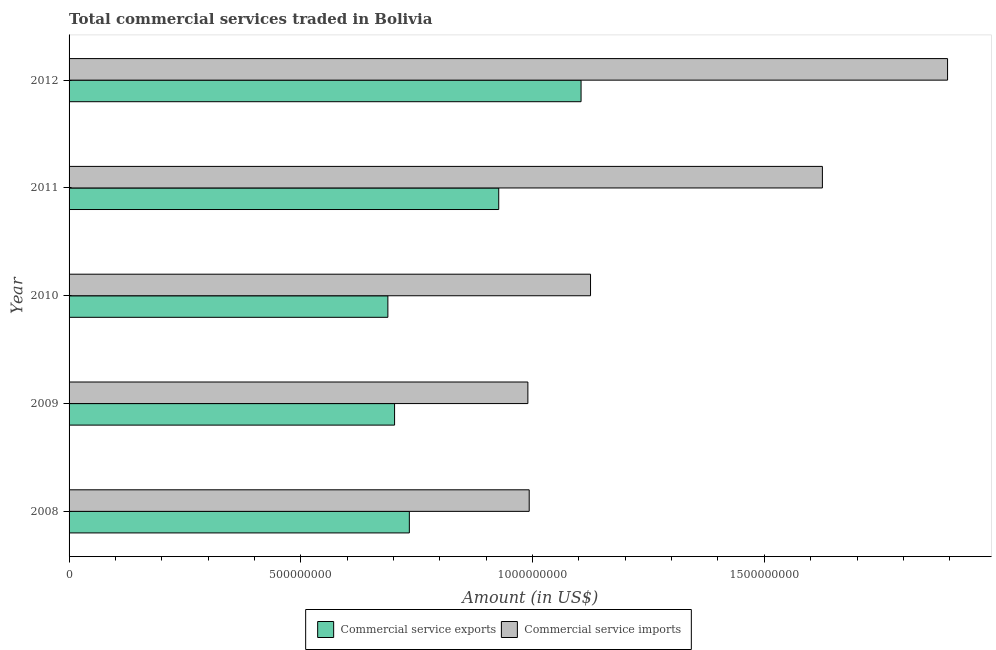Are the number of bars per tick equal to the number of legend labels?
Offer a terse response. Yes. Are the number of bars on each tick of the Y-axis equal?
Provide a succinct answer. Yes. What is the label of the 4th group of bars from the top?
Your response must be concise. 2009. What is the amount of commercial service exports in 2012?
Offer a terse response. 1.10e+09. Across all years, what is the maximum amount of commercial service imports?
Your answer should be very brief. 1.90e+09. Across all years, what is the minimum amount of commercial service exports?
Give a very brief answer. 6.88e+08. In which year was the amount of commercial service exports maximum?
Offer a terse response. 2012. What is the total amount of commercial service imports in the graph?
Offer a terse response. 6.63e+09. What is the difference between the amount of commercial service exports in 2010 and that in 2012?
Your response must be concise. -4.17e+08. What is the difference between the amount of commercial service exports in 2010 and the amount of commercial service imports in 2012?
Make the answer very short. -1.21e+09. What is the average amount of commercial service exports per year?
Your answer should be very brief. 8.31e+08. In the year 2009, what is the difference between the amount of commercial service imports and amount of commercial service exports?
Provide a short and direct response. 2.88e+08. In how many years, is the amount of commercial service exports greater than 1700000000 US$?
Your answer should be compact. 0. What is the ratio of the amount of commercial service imports in 2010 to that in 2012?
Your response must be concise. 0.59. What is the difference between the highest and the second highest amount of commercial service exports?
Your answer should be very brief. 1.78e+08. What is the difference between the highest and the lowest amount of commercial service imports?
Provide a succinct answer. 9.05e+08. In how many years, is the amount of commercial service imports greater than the average amount of commercial service imports taken over all years?
Offer a terse response. 2. Is the sum of the amount of commercial service exports in 2008 and 2012 greater than the maximum amount of commercial service imports across all years?
Make the answer very short. No. What does the 1st bar from the top in 2010 represents?
Keep it short and to the point. Commercial service imports. What does the 2nd bar from the bottom in 2011 represents?
Provide a short and direct response. Commercial service imports. How many bars are there?
Offer a terse response. 10. How many years are there in the graph?
Give a very brief answer. 5. What is the difference between two consecutive major ticks on the X-axis?
Your response must be concise. 5.00e+08. Are the values on the major ticks of X-axis written in scientific E-notation?
Provide a short and direct response. No. Does the graph contain any zero values?
Offer a terse response. No. Where does the legend appear in the graph?
Provide a succinct answer. Bottom center. How are the legend labels stacked?
Your response must be concise. Horizontal. What is the title of the graph?
Your answer should be very brief. Total commercial services traded in Bolivia. Does "Secondary" appear as one of the legend labels in the graph?
Offer a very short reply. No. What is the Amount (in US$) of Commercial service exports in 2008?
Give a very brief answer. 7.34e+08. What is the Amount (in US$) in Commercial service imports in 2008?
Provide a succinct answer. 9.93e+08. What is the Amount (in US$) of Commercial service exports in 2009?
Provide a succinct answer. 7.02e+08. What is the Amount (in US$) in Commercial service imports in 2009?
Ensure brevity in your answer.  9.90e+08. What is the Amount (in US$) of Commercial service exports in 2010?
Offer a terse response. 6.88e+08. What is the Amount (in US$) of Commercial service imports in 2010?
Your response must be concise. 1.13e+09. What is the Amount (in US$) in Commercial service exports in 2011?
Your answer should be very brief. 9.27e+08. What is the Amount (in US$) in Commercial service imports in 2011?
Ensure brevity in your answer.  1.63e+09. What is the Amount (in US$) in Commercial service exports in 2012?
Offer a terse response. 1.10e+09. What is the Amount (in US$) of Commercial service imports in 2012?
Your answer should be very brief. 1.90e+09. Across all years, what is the maximum Amount (in US$) in Commercial service exports?
Make the answer very short. 1.10e+09. Across all years, what is the maximum Amount (in US$) of Commercial service imports?
Keep it short and to the point. 1.90e+09. Across all years, what is the minimum Amount (in US$) of Commercial service exports?
Ensure brevity in your answer.  6.88e+08. Across all years, what is the minimum Amount (in US$) of Commercial service imports?
Ensure brevity in your answer.  9.90e+08. What is the total Amount (in US$) in Commercial service exports in the graph?
Provide a succinct answer. 4.16e+09. What is the total Amount (in US$) of Commercial service imports in the graph?
Keep it short and to the point. 6.63e+09. What is the difference between the Amount (in US$) in Commercial service exports in 2008 and that in 2009?
Offer a terse response. 3.18e+07. What is the difference between the Amount (in US$) of Commercial service imports in 2008 and that in 2009?
Make the answer very short. 2.86e+06. What is the difference between the Amount (in US$) in Commercial service exports in 2008 and that in 2010?
Ensure brevity in your answer.  4.63e+07. What is the difference between the Amount (in US$) in Commercial service imports in 2008 and that in 2010?
Keep it short and to the point. -1.32e+08. What is the difference between the Amount (in US$) in Commercial service exports in 2008 and that in 2011?
Give a very brief answer. -1.93e+08. What is the difference between the Amount (in US$) in Commercial service imports in 2008 and that in 2011?
Provide a succinct answer. -6.33e+08. What is the difference between the Amount (in US$) in Commercial service exports in 2008 and that in 2012?
Offer a terse response. -3.70e+08. What is the difference between the Amount (in US$) in Commercial service imports in 2008 and that in 2012?
Your response must be concise. -9.03e+08. What is the difference between the Amount (in US$) of Commercial service exports in 2009 and that in 2010?
Offer a terse response. 1.45e+07. What is the difference between the Amount (in US$) of Commercial service imports in 2009 and that in 2010?
Give a very brief answer. -1.35e+08. What is the difference between the Amount (in US$) in Commercial service exports in 2009 and that in 2011?
Your answer should be compact. -2.25e+08. What is the difference between the Amount (in US$) in Commercial service imports in 2009 and that in 2011?
Your answer should be compact. -6.35e+08. What is the difference between the Amount (in US$) in Commercial service exports in 2009 and that in 2012?
Provide a short and direct response. -4.02e+08. What is the difference between the Amount (in US$) of Commercial service imports in 2009 and that in 2012?
Offer a terse response. -9.05e+08. What is the difference between the Amount (in US$) in Commercial service exports in 2010 and that in 2011?
Make the answer very short. -2.39e+08. What is the difference between the Amount (in US$) of Commercial service imports in 2010 and that in 2011?
Give a very brief answer. -5.00e+08. What is the difference between the Amount (in US$) in Commercial service exports in 2010 and that in 2012?
Your response must be concise. -4.17e+08. What is the difference between the Amount (in US$) in Commercial service imports in 2010 and that in 2012?
Your response must be concise. -7.70e+08. What is the difference between the Amount (in US$) in Commercial service exports in 2011 and that in 2012?
Ensure brevity in your answer.  -1.78e+08. What is the difference between the Amount (in US$) in Commercial service imports in 2011 and that in 2012?
Make the answer very short. -2.70e+08. What is the difference between the Amount (in US$) in Commercial service exports in 2008 and the Amount (in US$) in Commercial service imports in 2009?
Offer a very short reply. -2.56e+08. What is the difference between the Amount (in US$) in Commercial service exports in 2008 and the Amount (in US$) in Commercial service imports in 2010?
Keep it short and to the point. -3.91e+08. What is the difference between the Amount (in US$) in Commercial service exports in 2008 and the Amount (in US$) in Commercial service imports in 2011?
Offer a terse response. -8.91e+08. What is the difference between the Amount (in US$) of Commercial service exports in 2008 and the Amount (in US$) of Commercial service imports in 2012?
Make the answer very short. -1.16e+09. What is the difference between the Amount (in US$) of Commercial service exports in 2009 and the Amount (in US$) of Commercial service imports in 2010?
Ensure brevity in your answer.  -4.23e+08. What is the difference between the Amount (in US$) of Commercial service exports in 2009 and the Amount (in US$) of Commercial service imports in 2011?
Your answer should be compact. -9.23e+08. What is the difference between the Amount (in US$) of Commercial service exports in 2009 and the Amount (in US$) of Commercial service imports in 2012?
Ensure brevity in your answer.  -1.19e+09. What is the difference between the Amount (in US$) in Commercial service exports in 2010 and the Amount (in US$) in Commercial service imports in 2011?
Provide a succinct answer. -9.37e+08. What is the difference between the Amount (in US$) of Commercial service exports in 2010 and the Amount (in US$) of Commercial service imports in 2012?
Give a very brief answer. -1.21e+09. What is the difference between the Amount (in US$) of Commercial service exports in 2011 and the Amount (in US$) of Commercial service imports in 2012?
Ensure brevity in your answer.  -9.68e+08. What is the average Amount (in US$) of Commercial service exports per year?
Provide a succinct answer. 8.31e+08. What is the average Amount (in US$) of Commercial service imports per year?
Your response must be concise. 1.33e+09. In the year 2008, what is the difference between the Amount (in US$) in Commercial service exports and Amount (in US$) in Commercial service imports?
Offer a very short reply. -2.59e+08. In the year 2009, what is the difference between the Amount (in US$) of Commercial service exports and Amount (in US$) of Commercial service imports?
Give a very brief answer. -2.88e+08. In the year 2010, what is the difference between the Amount (in US$) in Commercial service exports and Amount (in US$) in Commercial service imports?
Your response must be concise. -4.37e+08. In the year 2011, what is the difference between the Amount (in US$) in Commercial service exports and Amount (in US$) in Commercial service imports?
Provide a succinct answer. -6.98e+08. In the year 2012, what is the difference between the Amount (in US$) of Commercial service exports and Amount (in US$) of Commercial service imports?
Your answer should be very brief. -7.91e+08. What is the ratio of the Amount (in US$) in Commercial service exports in 2008 to that in 2009?
Your response must be concise. 1.05. What is the ratio of the Amount (in US$) of Commercial service exports in 2008 to that in 2010?
Your response must be concise. 1.07. What is the ratio of the Amount (in US$) of Commercial service imports in 2008 to that in 2010?
Your answer should be very brief. 0.88. What is the ratio of the Amount (in US$) in Commercial service exports in 2008 to that in 2011?
Your answer should be very brief. 0.79. What is the ratio of the Amount (in US$) of Commercial service imports in 2008 to that in 2011?
Provide a succinct answer. 0.61. What is the ratio of the Amount (in US$) of Commercial service exports in 2008 to that in 2012?
Offer a terse response. 0.66. What is the ratio of the Amount (in US$) in Commercial service imports in 2008 to that in 2012?
Your response must be concise. 0.52. What is the ratio of the Amount (in US$) of Commercial service imports in 2009 to that in 2010?
Offer a terse response. 0.88. What is the ratio of the Amount (in US$) of Commercial service exports in 2009 to that in 2011?
Your answer should be very brief. 0.76. What is the ratio of the Amount (in US$) of Commercial service imports in 2009 to that in 2011?
Offer a terse response. 0.61. What is the ratio of the Amount (in US$) in Commercial service exports in 2009 to that in 2012?
Provide a short and direct response. 0.64. What is the ratio of the Amount (in US$) in Commercial service imports in 2009 to that in 2012?
Your answer should be compact. 0.52. What is the ratio of the Amount (in US$) in Commercial service exports in 2010 to that in 2011?
Offer a terse response. 0.74. What is the ratio of the Amount (in US$) in Commercial service imports in 2010 to that in 2011?
Your answer should be compact. 0.69. What is the ratio of the Amount (in US$) in Commercial service exports in 2010 to that in 2012?
Your response must be concise. 0.62. What is the ratio of the Amount (in US$) of Commercial service imports in 2010 to that in 2012?
Keep it short and to the point. 0.59. What is the ratio of the Amount (in US$) in Commercial service exports in 2011 to that in 2012?
Keep it short and to the point. 0.84. What is the ratio of the Amount (in US$) in Commercial service imports in 2011 to that in 2012?
Your response must be concise. 0.86. What is the difference between the highest and the second highest Amount (in US$) in Commercial service exports?
Give a very brief answer. 1.78e+08. What is the difference between the highest and the second highest Amount (in US$) of Commercial service imports?
Provide a short and direct response. 2.70e+08. What is the difference between the highest and the lowest Amount (in US$) of Commercial service exports?
Give a very brief answer. 4.17e+08. What is the difference between the highest and the lowest Amount (in US$) of Commercial service imports?
Give a very brief answer. 9.05e+08. 